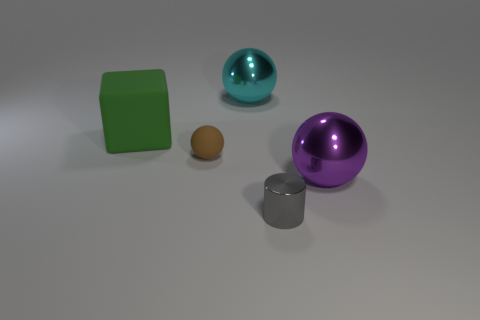Subtract all large balls. How many balls are left? 1 Subtract all purple spheres. How many spheres are left? 2 Subtract 1 cylinders. How many cylinders are left? 0 Add 5 purple metallic things. How many objects exist? 10 Subtract all gray balls. Subtract all red blocks. How many balls are left? 3 Add 1 blue matte blocks. How many blue matte blocks exist? 1 Subtract 0 purple cylinders. How many objects are left? 5 Subtract all cubes. How many objects are left? 4 Subtract all brown cubes. How many cyan balls are left? 1 Subtract all purple metallic spheres. Subtract all big green rubber cylinders. How many objects are left? 4 